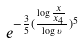<formula> <loc_0><loc_0><loc_500><loc_500>e ^ { - \frac { 3 } { 5 } ( \frac { \log \frac { x } { x _ { 4 } } } { \log \upsilon } ) ^ { 5 } }</formula> 